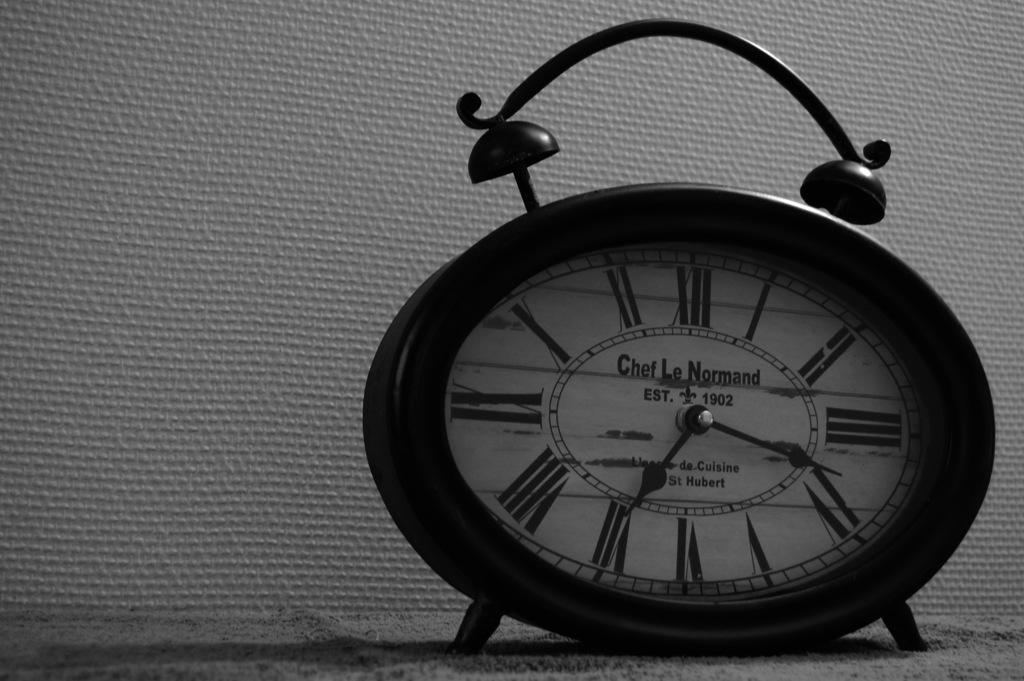<image>
Present a compact description of the photo's key features. a clock that says 'chef le normand' on the face of it 